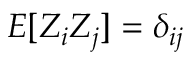<formula> <loc_0><loc_0><loc_500><loc_500>E [ Z _ { i } Z _ { j } ] = \delta _ { i j }</formula> 